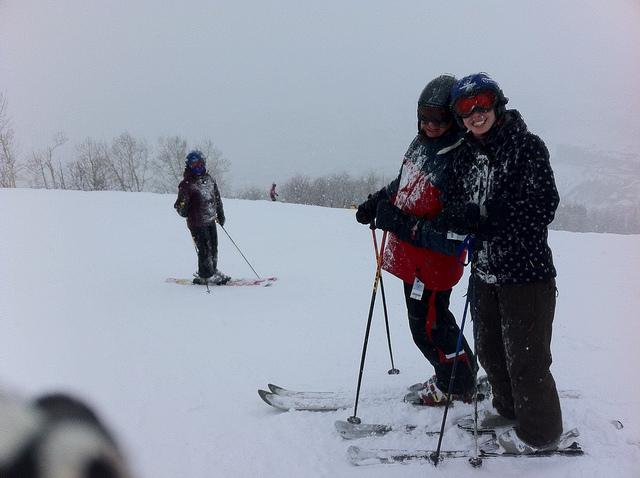To which elevation will the persons pictured here likely go to on their skis? lower 